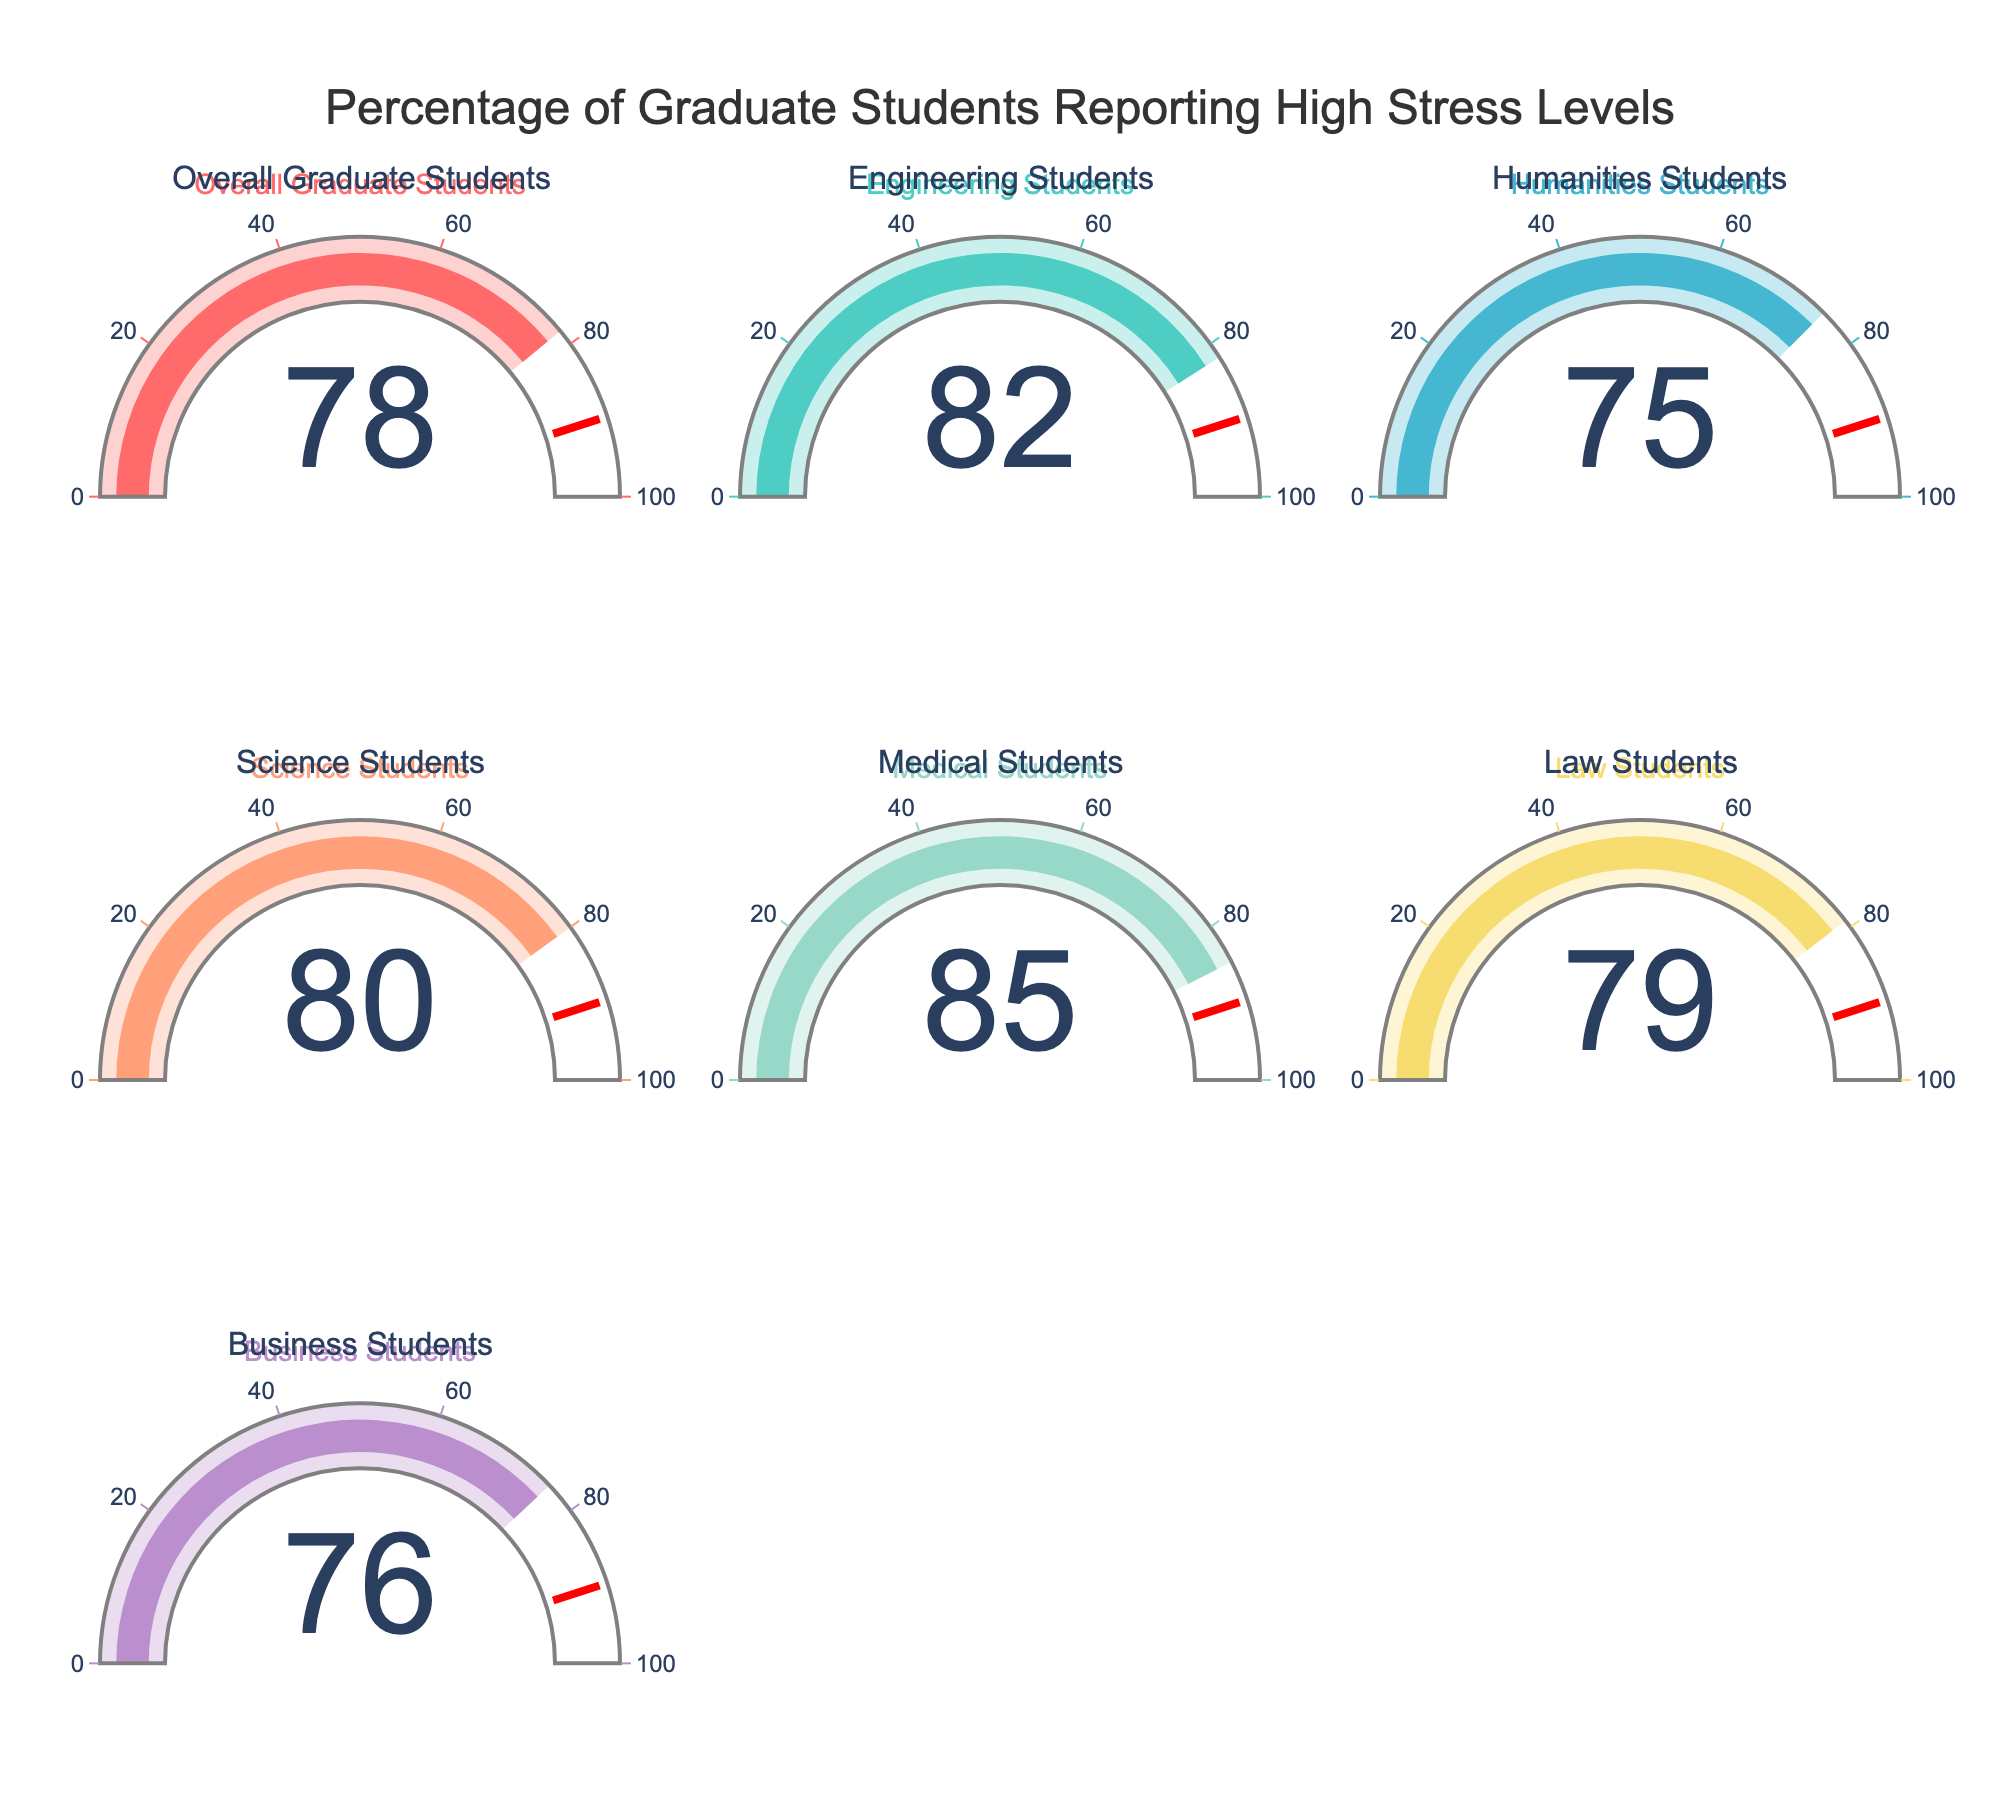What is the percentage of Engineering students reporting high stress levels? The Engineering students' gauge shows a percentage, which indicates the proportion of Engineering students experiencing high stress levels.
Answer: 82% Which category of students has the highest percentage of reporting high stress levels? Among all the categories, observe the values on each gauge. The category with the highest value is Medical Students.
Answer: Medical Students Is the percentage of Law students reporting high stress levels higher or lower than Humanities students? Compare the values on the gauges for Law and Humanities students. Law students have 79% and Humanities students have 75%.
Answer: Higher What is the average percentage of high stress levels reported by Science, Business, and Humanities students combined? Add the values for Science (80), Business (76), and Humanities (75) students, then divide by 3: (80 + 76 + 75) / 3 = 231 / 3.
Answer: 77% How much higher is the stress level percentage for Medical students compared to Business students? Subtract the percentage for Business students (76) from Medical students (85): 85 - 76.
Answer: 9% What is the title of the Gauge Chart? The title is displayed prominently at the top center of the figure. It is "Percentage of Graduate Students Reporting High Stress Levels".
Answer: Percentage of Graduate Students Reporting High Stress Levels Which two student categories report nearly the same percentage of high stress levels? Compare the values on the gauges to find categories with close percentages. Law students (79%) and Overall Graduate Students (78%) report nearly the same percentage.
Answer: Law Students and Overall Graduate Students How does the percentage of stress levels reported by Science students compare to the overall graduate students? Compare the values for Science students (80) and Overall Graduate Students (78). Science students report a higher stress level.
Answer: Higher What is the combined total percentage of high stress levels for Engineering and Law students? Add the percentages for Engineering (82) and Law (79) students: 82 + 79 = 161.
Answer: 161% If the target threshold value of high stress levels is set at 90%, did any category exceed this threshold? Review the gauge values and compare each one to the threshold value of 90%. None of the categories exceed the 90% threshold.
Answer: No 